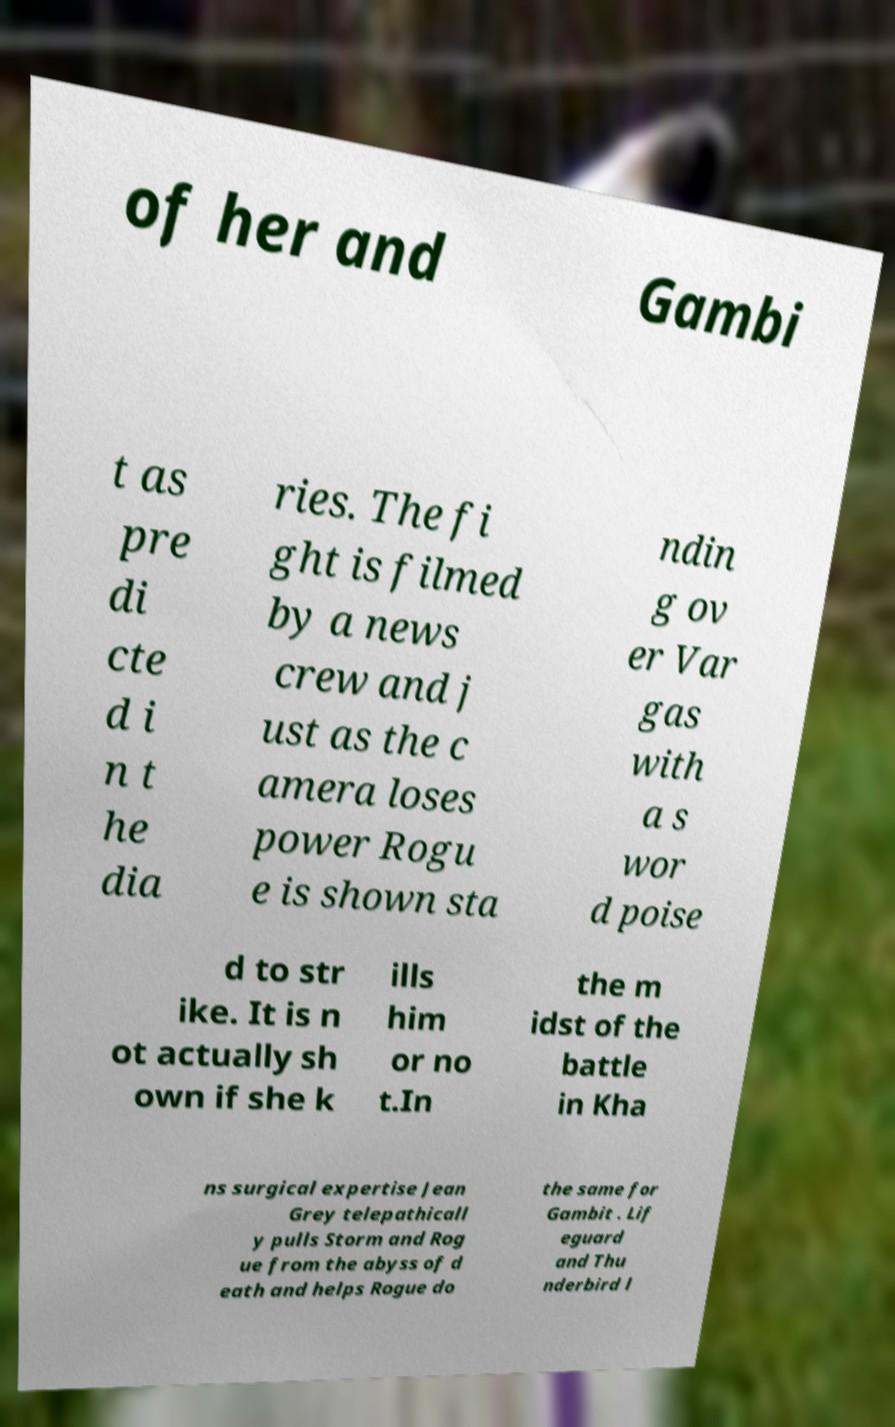Can you accurately transcribe the text from the provided image for me? of her and Gambi t as pre di cte d i n t he dia ries. The fi ght is filmed by a news crew and j ust as the c amera loses power Rogu e is shown sta ndin g ov er Var gas with a s wor d poise d to str ike. It is n ot actually sh own if she k ills him or no t.In the m idst of the battle in Kha ns surgical expertise Jean Grey telepathicall y pulls Storm and Rog ue from the abyss of d eath and helps Rogue do the same for Gambit . Lif eguard and Thu nderbird l 